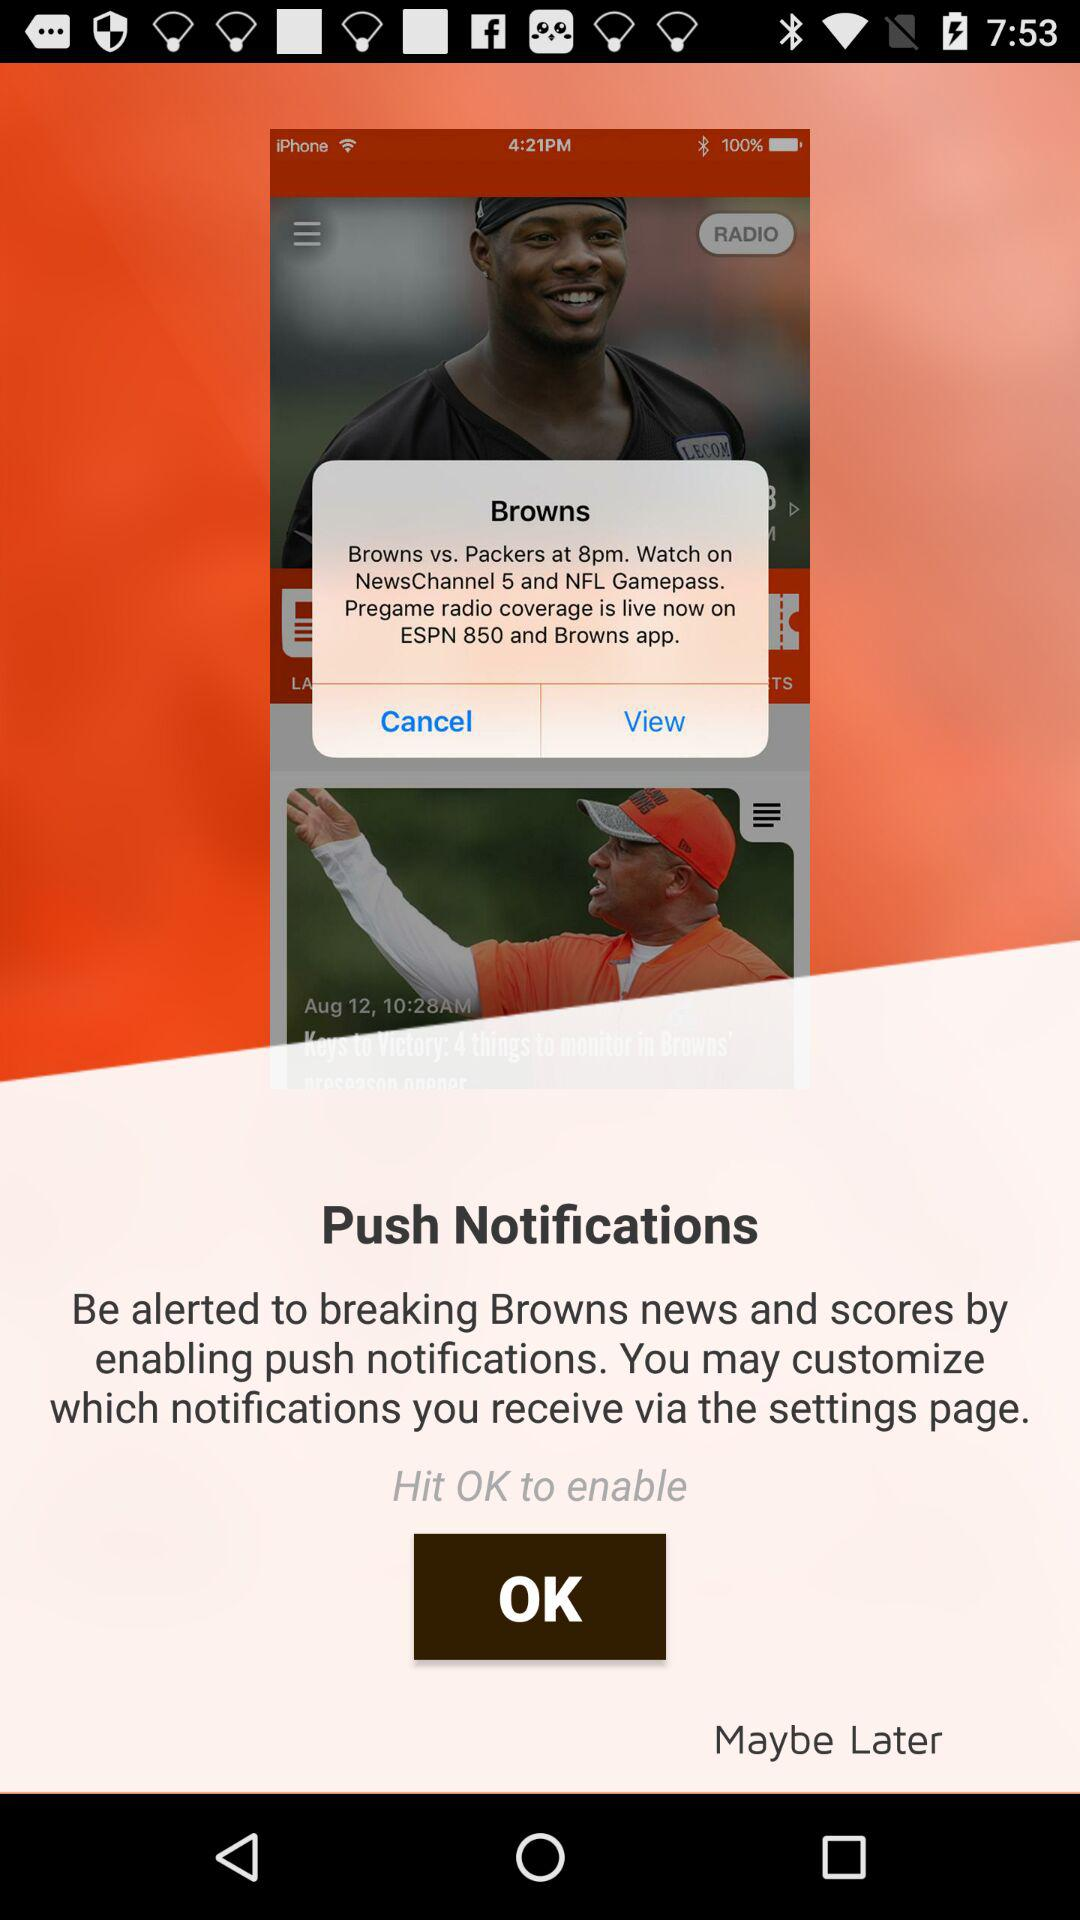What should be done to enable the app? To enable the app, you should hit the "OK" button. 